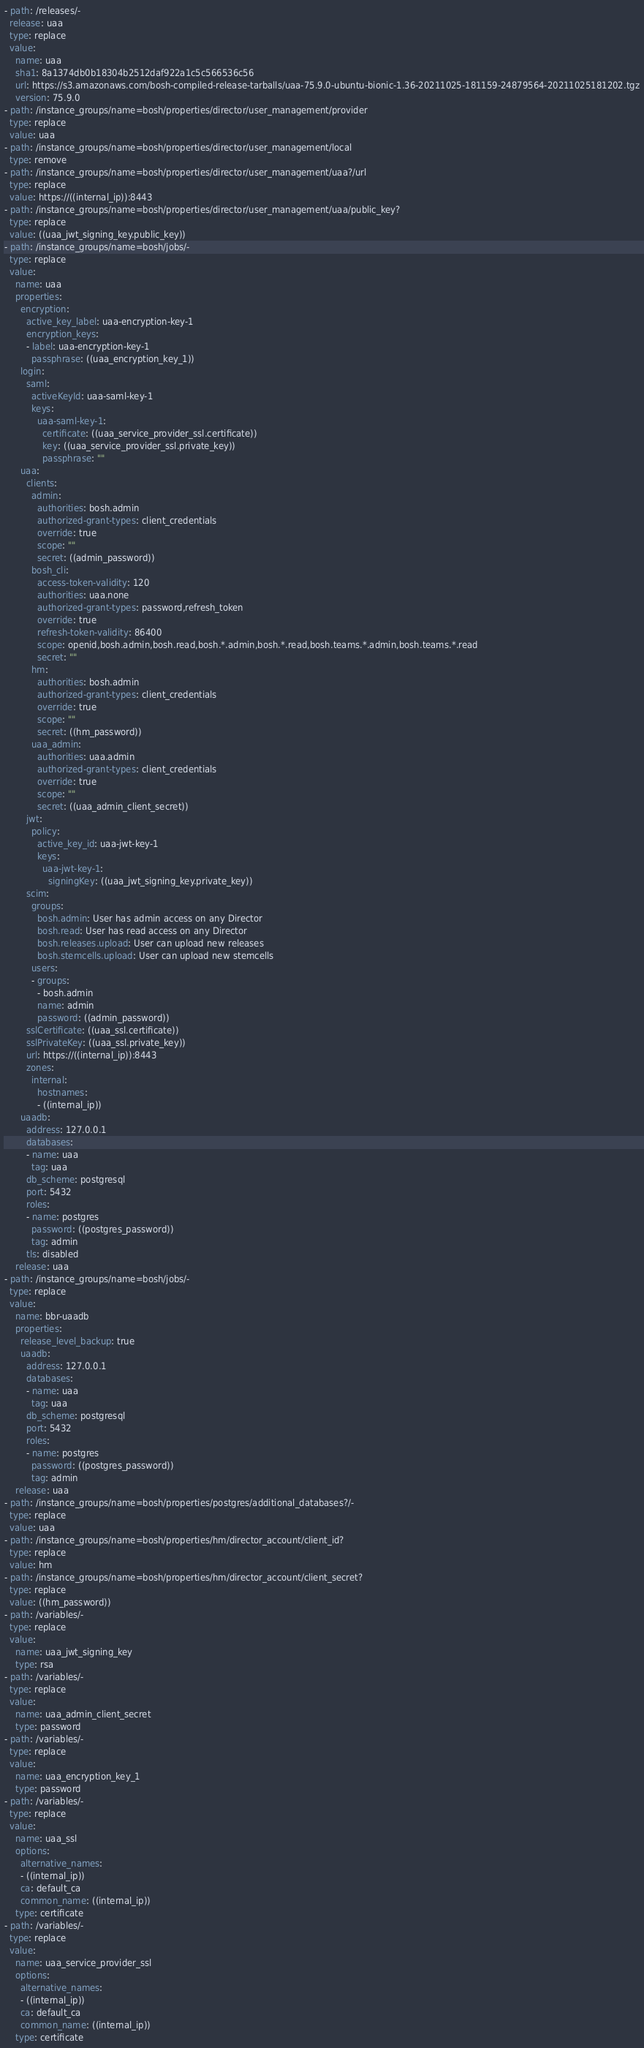<code> <loc_0><loc_0><loc_500><loc_500><_YAML_>- path: /releases/-
  release: uaa
  type: replace
  value:
    name: uaa
    sha1: 8a1374db0b18304b2512daf922a1c5c566536c56
    url: https://s3.amazonaws.com/bosh-compiled-release-tarballs/uaa-75.9.0-ubuntu-bionic-1.36-20211025-181159-24879564-20211025181202.tgz
    version: 75.9.0
- path: /instance_groups/name=bosh/properties/director/user_management/provider
  type: replace
  value: uaa
- path: /instance_groups/name=bosh/properties/director/user_management/local
  type: remove
- path: /instance_groups/name=bosh/properties/director/user_management/uaa?/url
  type: replace
  value: https://((internal_ip)):8443
- path: /instance_groups/name=bosh/properties/director/user_management/uaa/public_key?
  type: replace
  value: ((uaa_jwt_signing_key.public_key))
- path: /instance_groups/name=bosh/jobs/-
  type: replace
  value:
    name: uaa
    properties:
      encryption:
        active_key_label: uaa-encryption-key-1
        encryption_keys:
        - label: uaa-encryption-key-1
          passphrase: ((uaa_encryption_key_1))
      login:
        saml:
          activeKeyId: uaa-saml-key-1
          keys:
            uaa-saml-key-1:
              certificate: ((uaa_service_provider_ssl.certificate))
              key: ((uaa_service_provider_ssl.private_key))
              passphrase: ""
      uaa:
        clients:
          admin:
            authorities: bosh.admin
            authorized-grant-types: client_credentials
            override: true
            scope: ""
            secret: ((admin_password))
          bosh_cli:
            access-token-validity: 120
            authorities: uaa.none
            authorized-grant-types: password,refresh_token
            override: true
            refresh-token-validity: 86400
            scope: openid,bosh.admin,bosh.read,bosh.*.admin,bosh.*.read,bosh.teams.*.admin,bosh.teams.*.read
            secret: ""
          hm:
            authorities: bosh.admin
            authorized-grant-types: client_credentials
            override: true
            scope: ""
            secret: ((hm_password))
          uaa_admin:
            authorities: uaa.admin
            authorized-grant-types: client_credentials
            override: true
            scope: ""
            secret: ((uaa_admin_client_secret))
        jwt:
          policy:
            active_key_id: uaa-jwt-key-1
            keys:
              uaa-jwt-key-1:
                signingKey: ((uaa_jwt_signing_key.private_key))
        scim:
          groups:
            bosh.admin: User has admin access on any Director
            bosh.read: User has read access on any Director
            bosh.releases.upload: User can upload new releases
            bosh.stemcells.upload: User can upload new stemcells
          users:
          - groups:
            - bosh.admin
            name: admin
            password: ((admin_password))
        sslCertificate: ((uaa_ssl.certificate))
        sslPrivateKey: ((uaa_ssl.private_key))
        url: https://((internal_ip)):8443
        zones:
          internal:
            hostnames:
            - ((internal_ip))
      uaadb:
        address: 127.0.0.1
        databases:
        - name: uaa
          tag: uaa
        db_scheme: postgresql
        port: 5432
        roles:
        - name: postgres
          password: ((postgres_password))
          tag: admin
        tls: disabled
    release: uaa
- path: /instance_groups/name=bosh/jobs/-
  type: replace
  value:
    name: bbr-uaadb
    properties:
      release_level_backup: true
      uaadb:
        address: 127.0.0.1
        databases:
        - name: uaa
          tag: uaa
        db_scheme: postgresql
        port: 5432
        roles:
        - name: postgres
          password: ((postgres_password))
          tag: admin
    release: uaa
- path: /instance_groups/name=bosh/properties/postgres/additional_databases?/-
  type: replace
  value: uaa
- path: /instance_groups/name=bosh/properties/hm/director_account/client_id?
  type: replace
  value: hm
- path: /instance_groups/name=bosh/properties/hm/director_account/client_secret?
  type: replace
  value: ((hm_password))
- path: /variables/-
  type: replace
  value:
    name: uaa_jwt_signing_key
    type: rsa
- path: /variables/-
  type: replace
  value:
    name: uaa_admin_client_secret
    type: password
- path: /variables/-
  type: replace
  value:
    name: uaa_encryption_key_1
    type: password
- path: /variables/-
  type: replace
  value:
    name: uaa_ssl
    options:
      alternative_names:
      - ((internal_ip))
      ca: default_ca
      common_name: ((internal_ip))
    type: certificate
- path: /variables/-
  type: replace
  value:
    name: uaa_service_provider_ssl
    options:
      alternative_names:
      - ((internal_ip))
      ca: default_ca
      common_name: ((internal_ip))
    type: certificate
</code> 